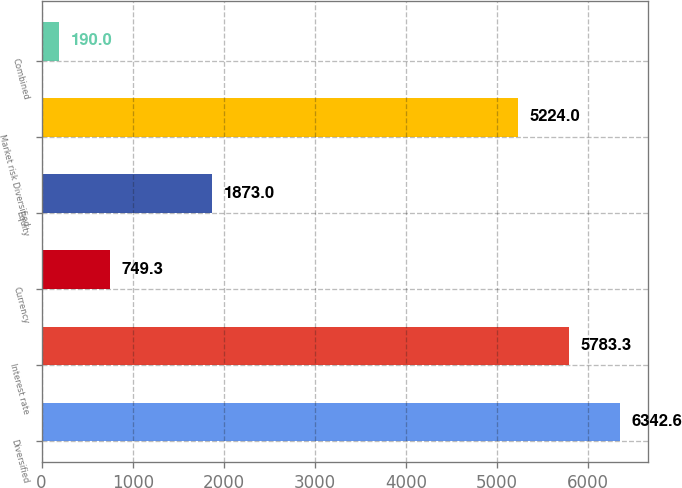Convert chart. <chart><loc_0><loc_0><loc_500><loc_500><bar_chart><fcel>Diversified<fcel>Interest rate<fcel>Currency<fcel>Equity<fcel>Market risk Diversified<fcel>Combined<nl><fcel>6342.6<fcel>5783.3<fcel>749.3<fcel>1873<fcel>5224<fcel>190<nl></chart> 